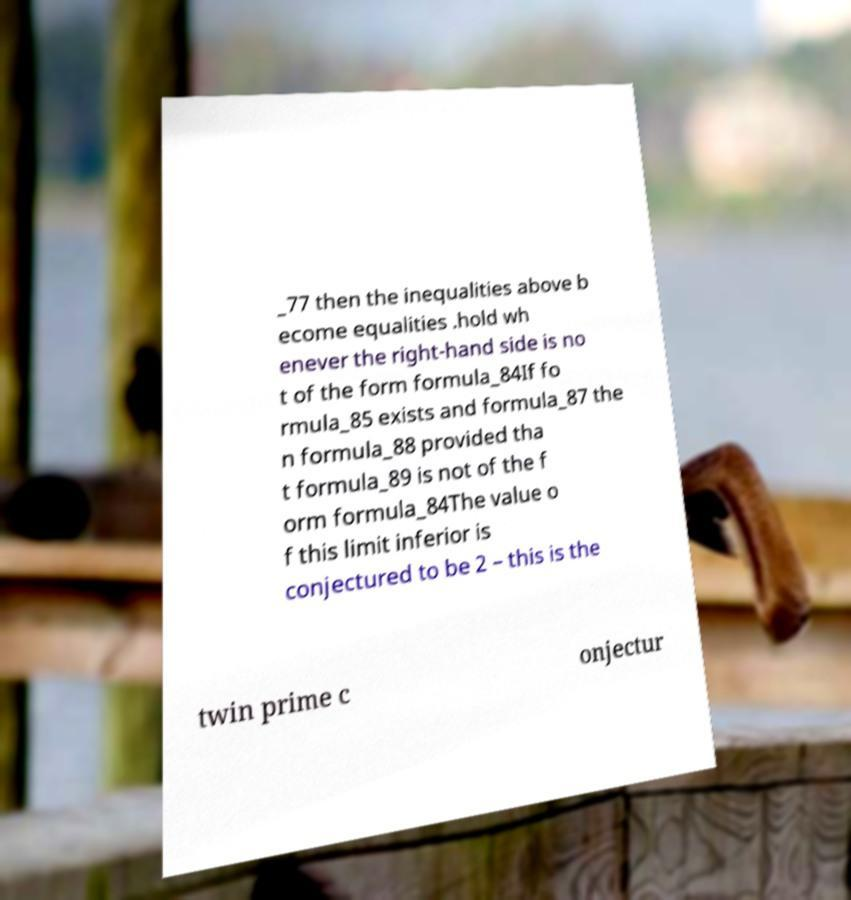Can you read and provide the text displayed in the image?This photo seems to have some interesting text. Can you extract and type it out for me? _77 then the inequalities above b ecome equalities .hold wh enever the right-hand side is no t of the form formula_84If fo rmula_85 exists and formula_87 the n formula_88 provided tha t formula_89 is not of the f orm formula_84The value o f this limit inferior is conjectured to be 2 – this is the twin prime c onjectur 